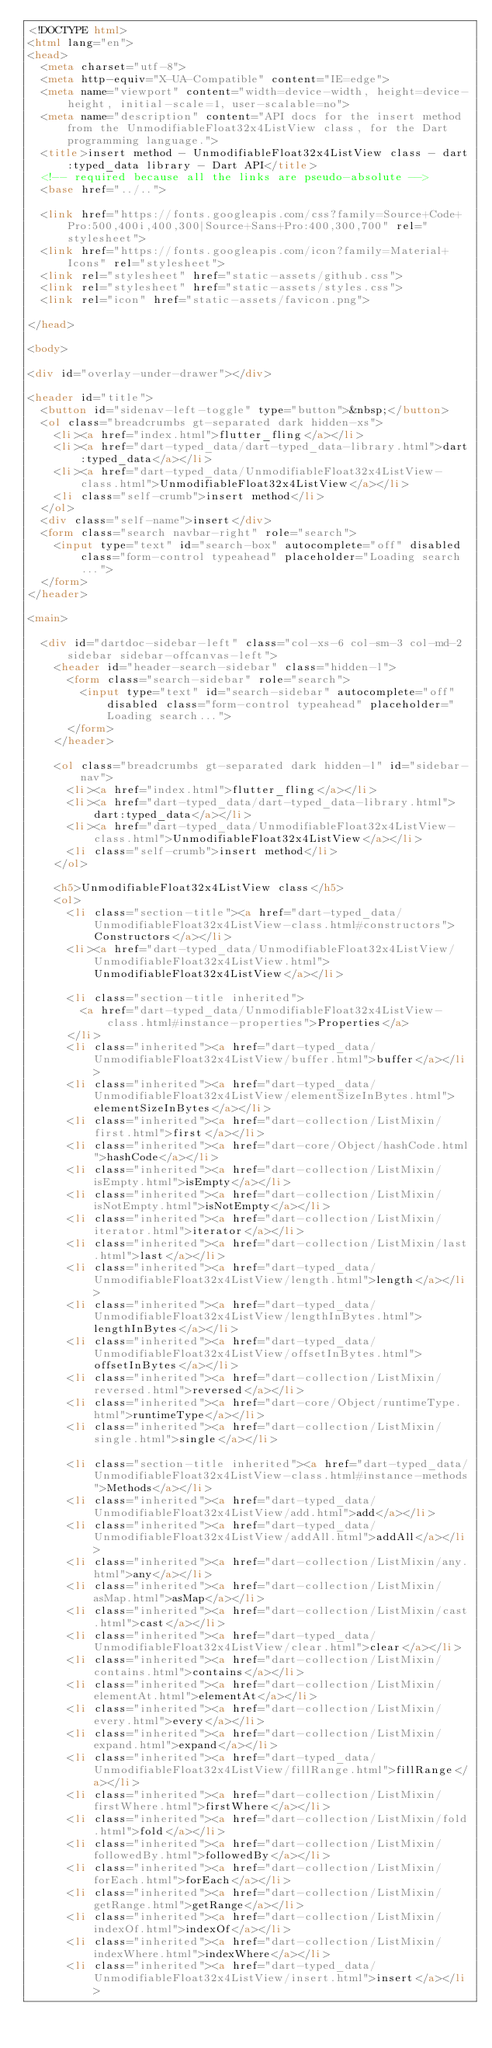<code> <loc_0><loc_0><loc_500><loc_500><_HTML_><!DOCTYPE html>
<html lang="en">
<head>
  <meta charset="utf-8">
  <meta http-equiv="X-UA-Compatible" content="IE=edge">
  <meta name="viewport" content="width=device-width, height=device-height, initial-scale=1, user-scalable=no">
  <meta name="description" content="API docs for the insert method from the UnmodifiableFloat32x4ListView class, for the Dart programming language.">
  <title>insert method - UnmodifiableFloat32x4ListView class - dart:typed_data library - Dart API</title>
  <!-- required because all the links are pseudo-absolute -->
  <base href="../..">

  <link href="https://fonts.googleapis.com/css?family=Source+Code+Pro:500,400i,400,300|Source+Sans+Pro:400,300,700" rel="stylesheet">
  <link href="https://fonts.googleapis.com/icon?family=Material+Icons" rel="stylesheet">
  <link rel="stylesheet" href="static-assets/github.css">
  <link rel="stylesheet" href="static-assets/styles.css">
  <link rel="icon" href="static-assets/favicon.png">
  
</head>

<body>

<div id="overlay-under-drawer"></div>

<header id="title">
  <button id="sidenav-left-toggle" type="button">&nbsp;</button>
  <ol class="breadcrumbs gt-separated dark hidden-xs">
    <li><a href="index.html">flutter_fling</a></li>
    <li><a href="dart-typed_data/dart-typed_data-library.html">dart:typed_data</a></li>
    <li><a href="dart-typed_data/UnmodifiableFloat32x4ListView-class.html">UnmodifiableFloat32x4ListView</a></li>
    <li class="self-crumb">insert method</li>
  </ol>
  <div class="self-name">insert</div>
  <form class="search navbar-right" role="search">
    <input type="text" id="search-box" autocomplete="off" disabled class="form-control typeahead" placeholder="Loading search...">
  </form>
</header>

<main>

  <div id="dartdoc-sidebar-left" class="col-xs-6 col-sm-3 col-md-2 sidebar sidebar-offcanvas-left">
    <header id="header-search-sidebar" class="hidden-l">
      <form class="search-sidebar" role="search">
        <input type="text" id="search-sidebar" autocomplete="off" disabled class="form-control typeahead" placeholder="Loading search...">
      </form>
    </header>
    
    <ol class="breadcrumbs gt-separated dark hidden-l" id="sidebar-nav">
      <li><a href="index.html">flutter_fling</a></li>
      <li><a href="dart-typed_data/dart-typed_data-library.html">dart:typed_data</a></li>
      <li><a href="dart-typed_data/UnmodifiableFloat32x4ListView-class.html">UnmodifiableFloat32x4ListView</a></li>
      <li class="self-crumb">insert method</li>
    </ol>
    
    <h5>UnmodifiableFloat32x4ListView class</h5>
    <ol>
      <li class="section-title"><a href="dart-typed_data/UnmodifiableFloat32x4ListView-class.html#constructors">Constructors</a></li>
      <li><a href="dart-typed_data/UnmodifiableFloat32x4ListView/UnmodifiableFloat32x4ListView.html">UnmodifiableFloat32x4ListView</a></li>
    
      <li class="section-title inherited">
        <a href="dart-typed_data/UnmodifiableFloat32x4ListView-class.html#instance-properties">Properties</a>
      </li>
      <li class="inherited"><a href="dart-typed_data/UnmodifiableFloat32x4ListView/buffer.html">buffer</a></li>
      <li class="inherited"><a href="dart-typed_data/UnmodifiableFloat32x4ListView/elementSizeInBytes.html">elementSizeInBytes</a></li>
      <li class="inherited"><a href="dart-collection/ListMixin/first.html">first</a></li>
      <li class="inherited"><a href="dart-core/Object/hashCode.html">hashCode</a></li>
      <li class="inherited"><a href="dart-collection/ListMixin/isEmpty.html">isEmpty</a></li>
      <li class="inherited"><a href="dart-collection/ListMixin/isNotEmpty.html">isNotEmpty</a></li>
      <li class="inherited"><a href="dart-collection/ListMixin/iterator.html">iterator</a></li>
      <li class="inherited"><a href="dart-collection/ListMixin/last.html">last</a></li>
      <li class="inherited"><a href="dart-typed_data/UnmodifiableFloat32x4ListView/length.html">length</a></li>
      <li class="inherited"><a href="dart-typed_data/UnmodifiableFloat32x4ListView/lengthInBytes.html">lengthInBytes</a></li>
      <li class="inherited"><a href="dart-typed_data/UnmodifiableFloat32x4ListView/offsetInBytes.html">offsetInBytes</a></li>
      <li class="inherited"><a href="dart-collection/ListMixin/reversed.html">reversed</a></li>
      <li class="inherited"><a href="dart-core/Object/runtimeType.html">runtimeType</a></li>
      <li class="inherited"><a href="dart-collection/ListMixin/single.html">single</a></li>
    
      <li class="section-title inherited"><a href="dart-typed_data/UnmodifiableFloat32x4ListView-class.html#instance-methods">Methods</a></li>
      <li class="inherited"><a href="dart-typed_data/UnmodifiableFloat32x4ListView/add.html">add</a></li>
      <li class="inherited"><a href="dart-typed_data/UnmodifiableFloat32x4ListView/addAll.html">addAll</a></li>
      <li class="inherited"><a href="dart-collection/ListMixin/any.html">any</a></li>
      <li class="inherited"><a href="dart-collection/ListMixin/asMap.html">asMap</a></li>
      <li class="inherited"><a href="dart-collection/ListMixin/cast.html">cast</a></li>
      <li class="inherited"><a href="dart-typed_data/UnmodifiableFloat32x4ListView/clear.html">clear</a></li>
      <li class="inherited"><a href="dart-collection/ListMixin/contains.html">contains</a></li>
      <li class="inherited"><a href="dart-collection/ListMixin/elementAt.html">elementAt</a></li>
      <li class="inherited"><a href="dart-collection/ListMixin/every.html">every</a></li>
      <li class="inherited"><a href="dart-collection/ListMixin/expand.html">expand</a></li>
      <li class="inherited"><a href="dart-typed_data/UnmodifiableFloat32x4ListView/fillRange.html">fillRange</a></li>
      <li class="inherited"><a href="dart-collection/ListMixin/firstWhere.html">firstWhere</a></li>
      <li class="inherited"><a href="dart-collection/ListMixin/fold.html">fold</a></li>
      <li class="inherited"><a href="dart-collection/ListMixin/followedBy.html">followedBy</a></li>
      <li class="inherited"><a href="dart-collection/ListMixin/forEach.html">forEach</a></li>
      <li class="inherited"><a href="dart-collection/ListMixin/getRange.html">getRange</a></li>
      <li class="inherited"><a href="dart-collection/ListMixin/indexOf.html">indexOf</a></li>
      <li class="inherited"><a href="dart-collection/ListMixin/indexWhere.html">indexWhere</a></li>
      <li class="inherited"><a href="dart-typed_data/UnmodifiableFloat32x4ListView/insert.html">insert</a></li></code> 